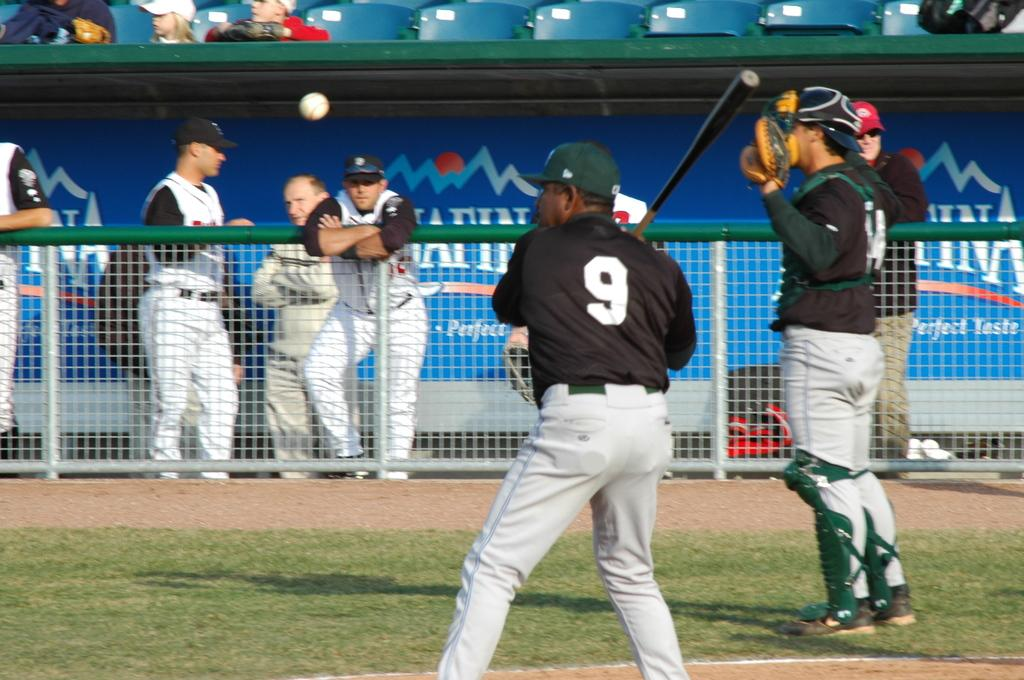Provide a one-sentence caption for the provided image. Number 9 is about to hit the baseball. 